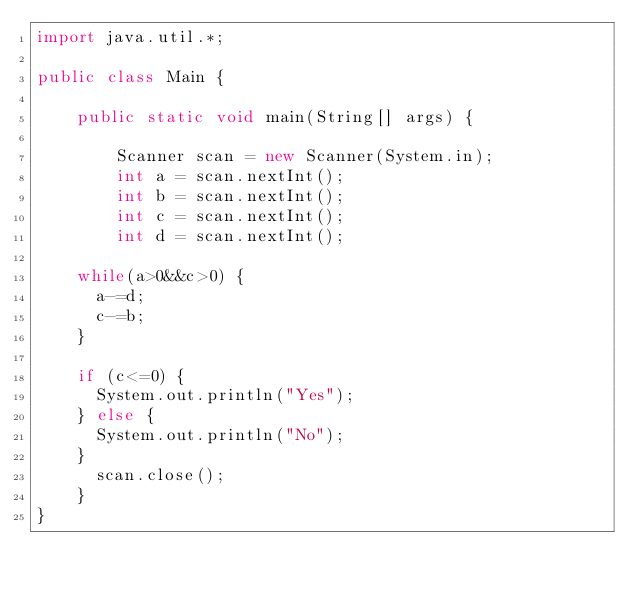<code> <loc_0><loc_0><loc_500><loc_500><_Java_>import java.util.*;

public class Main {

    public static void main(String[] args) {

        Scanner scan = new Scanner(System.in);
        int a = scan.nextInt();
        int b = scan.nextInt();
        int c = scan.nextInt();
        int d = scan.nextInt();

		while(a>0&&c>0) {
			a-=d;
			c-=b;
		}

		if (c<=0) {
			System.out.println("Yes");
		} else {
			System.out.println("No");
		}
	    scan.close();	
    }
}</code> 